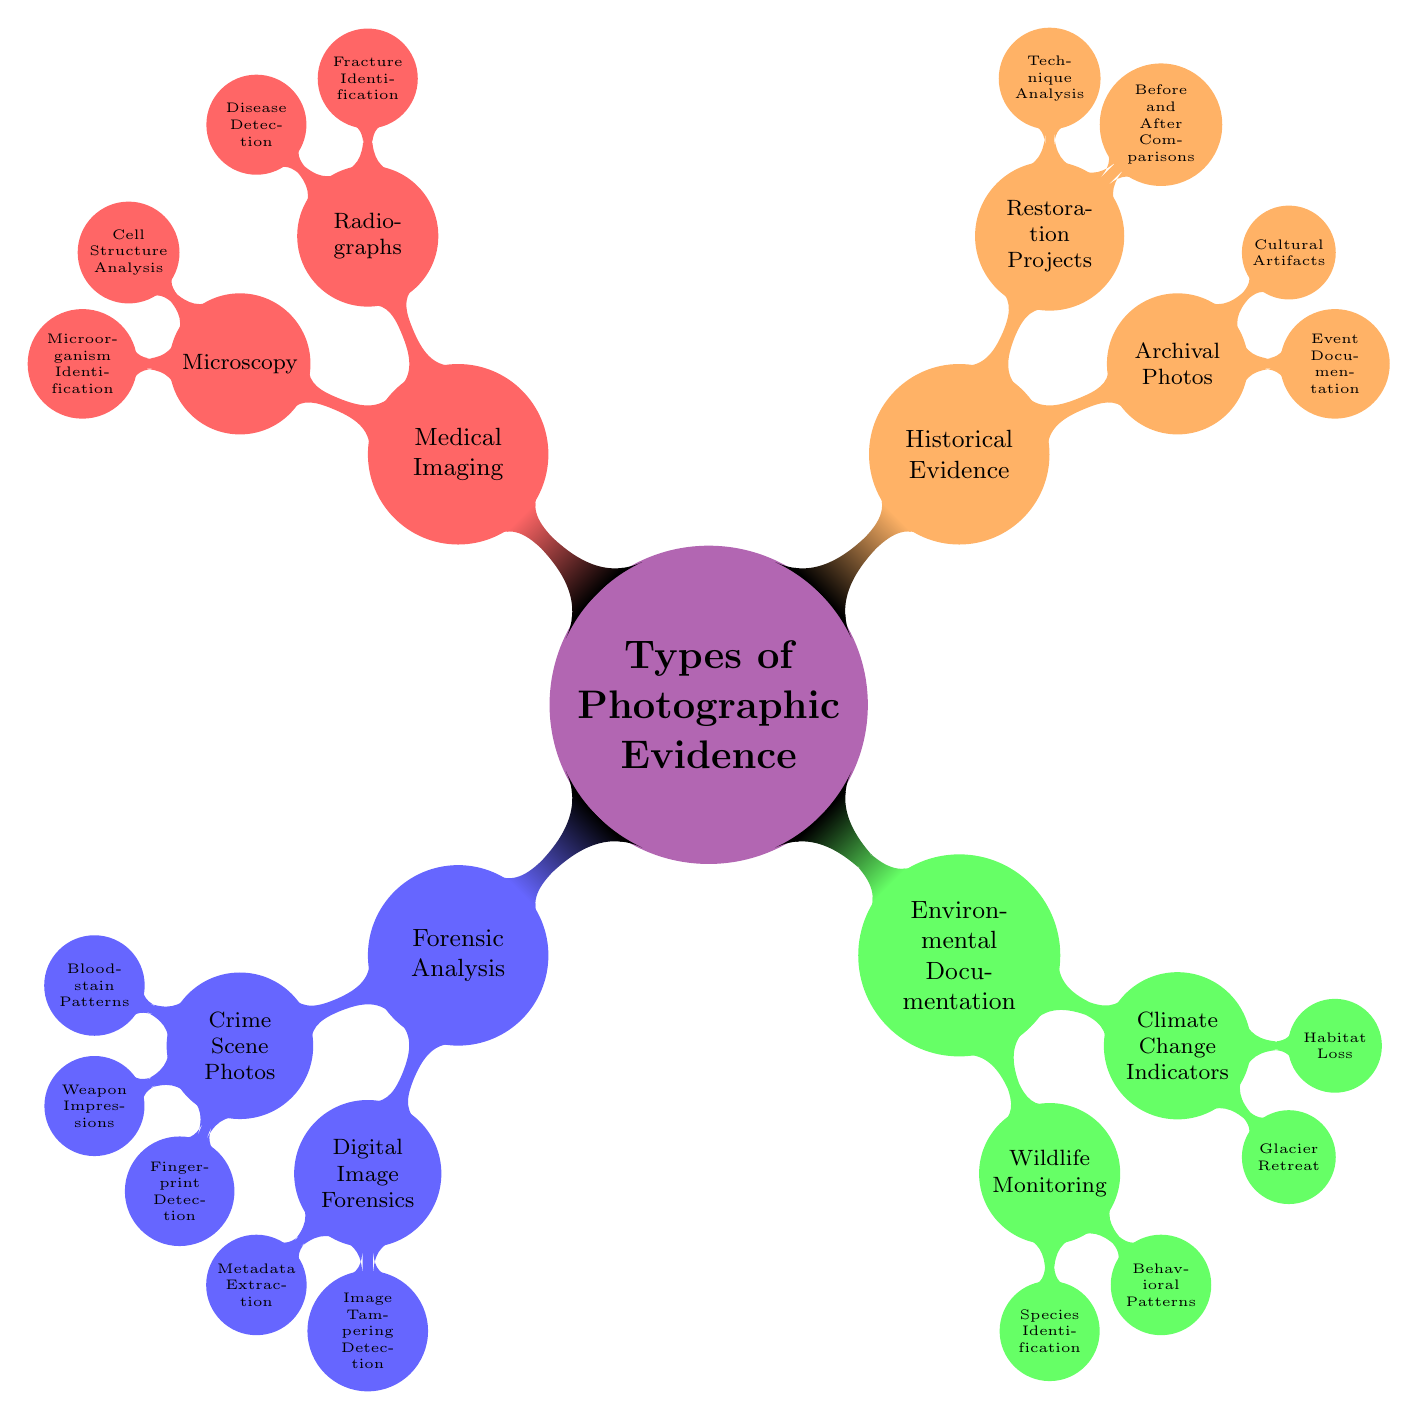What are the four main categories of photographic evidence depicted in the diagram? The diagram lists four main categories under the central concept "Types of Photographic Evidence": Forensic Analysis, Environmental Documentation, Historical Evidence, and Medical Imaging.
Answer: Forensic Analysis, Environmental Documentation, Historical Evidence, Medical Imaging How many subcategories are there under "Forensic Analysis"? Under "Forensic Analysis," there are two subcategories: Crime Scene Photos and Digital Image Forensics. Therefore, the number of subcategories is 2.
Answer: 2 What specific analysis does the "Medical Imaging" category encompass? The "Medical Imaging" category includes two main analyses: Radiographs and Microscopy. Each of these has further subdivisions focusing on specific types of identification and detection.
Answer: Radiographs, Microscopy Which type of photographic evidence focuses on species identification? The type of photographic evidence focusing on species identification is part of Environmental Documentation, specifically under Wildlife Monitoring.
Answer: Wildlife Monitoring In the Historical Evidence category, which specific type involves comparisons? In the Historical Evidence category, the specific type that involves comparisons is Restoration Projects, which encompasses Before and After Comparisons.
Answer: Before and After Comparisons What is the relationship between "Digital Image Forensics" and "Metadata Extraction"? "Digital Image Forensics" is a subcategory of "Forensic Analysis," and "Metadata Extraction" is a sub-item within "Digital Image Forensics." Thus, the relationship is that "Metadata Extraction" is a specific technique used in "Digital Image Forensics."
Answer: Sub-item of Digital Image Forensics How many specific items are listed under "Radiographs"? Under "Radiographs," there are two specific items listed: Fracture Identification and Disease Detection. Therefore, the total count is 2.
Answer: 2 What are the two main focuses of Climate Change Indicators? The two main focuses of Climate Change Indicators are Glacier Retreat and Habitat Loss, both of which are listed as sub-items under the Climate Change Indicators category.
Answer: Glacier Retreat, Habitat Loss 